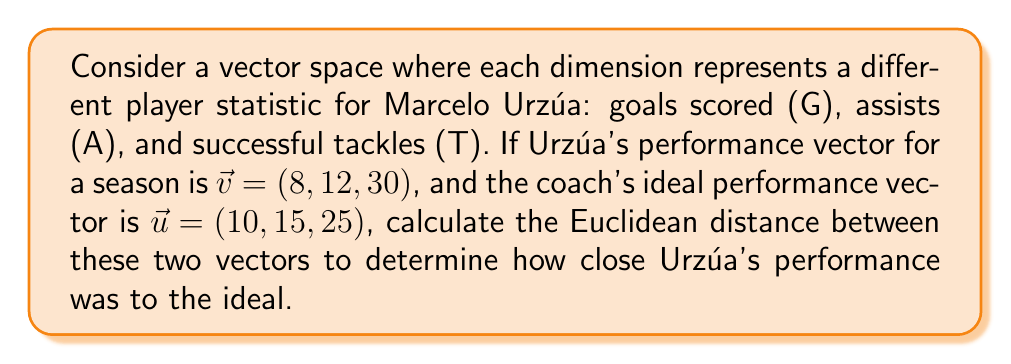Give your solution to this math problem. To solve this problem, we'll use the Euclidean distance formula in a 3-dimensional vector space:

1) The Euclidean distance formula for two vectors $\vec{a} = (a_1, a_2, a_3)$ and $\vec{b} = (b_1, b_2, b_3)$ is:

   $$d = \sqrt{(a_1 - b_1)^2 + (a_2 - b_2)^2 + (a_3 - b_3)^2}$$

2) In our case:
   $\vec{v} = (8, 12, 30)$ and $\vec{u} = (10, 15, 25)$

3) Let's substitute these values into the formula:

   $$d = \sqrt{(8 - 10)^2 + (12 - 15)^2 + (30 - 25)^2}$$

4) Simplify inside the parentheses:

   $$d = \sqrt{(-2)^2 + (-3)^2 + (5)^2}$$

5) Calculate the squares:

   $$d = \sqrt{4 + 9 + 25}$$

6) Sum inside the square root:

   $$d = \sqrt{38}$$

7) The square root of 38 is approximately 6.16.

Therefore, the Euclidean distance between Urzúa's performance vector and the ideal performance vector is approximately 6.16 units in this vector space.
Answer: $\sqrt{38} \approx 6.16$ 